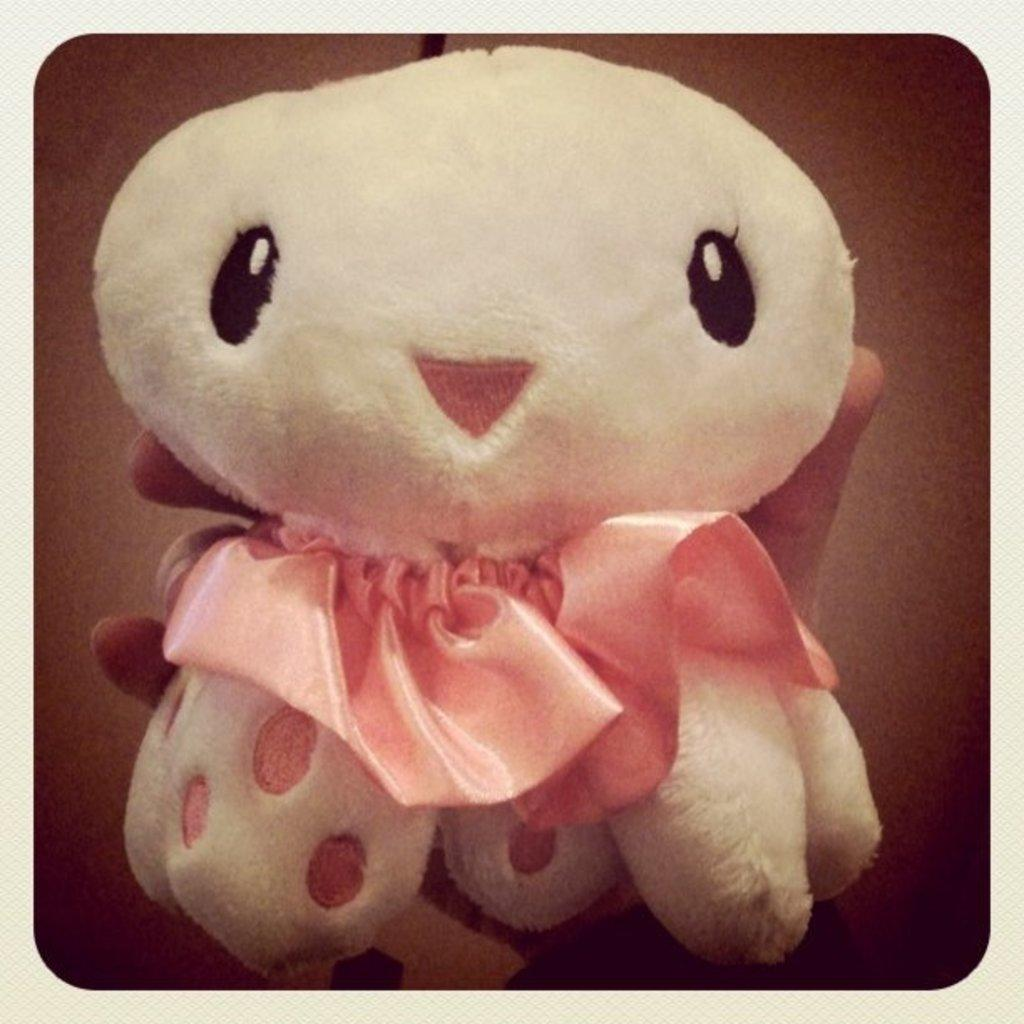What is being held by the person's hand in the image? The facts do not specify what the object is, only that a person's hand is holding it. Can you describe the position or gesture of the hand in the image? The facts do not provide enough information to describe the position or gesture of the hand. Is the hand holding the object in a particular way or with a specific purpose? The facts do not provide enough information to determine the purpose or manner of holding the object. What is the distribution of the son's toys in the image? There is no mention of a son or toys in the image, only a person's hand holding an object. In which country was the image taken? The facts do not provide any information about the location or country where the image was taken. 